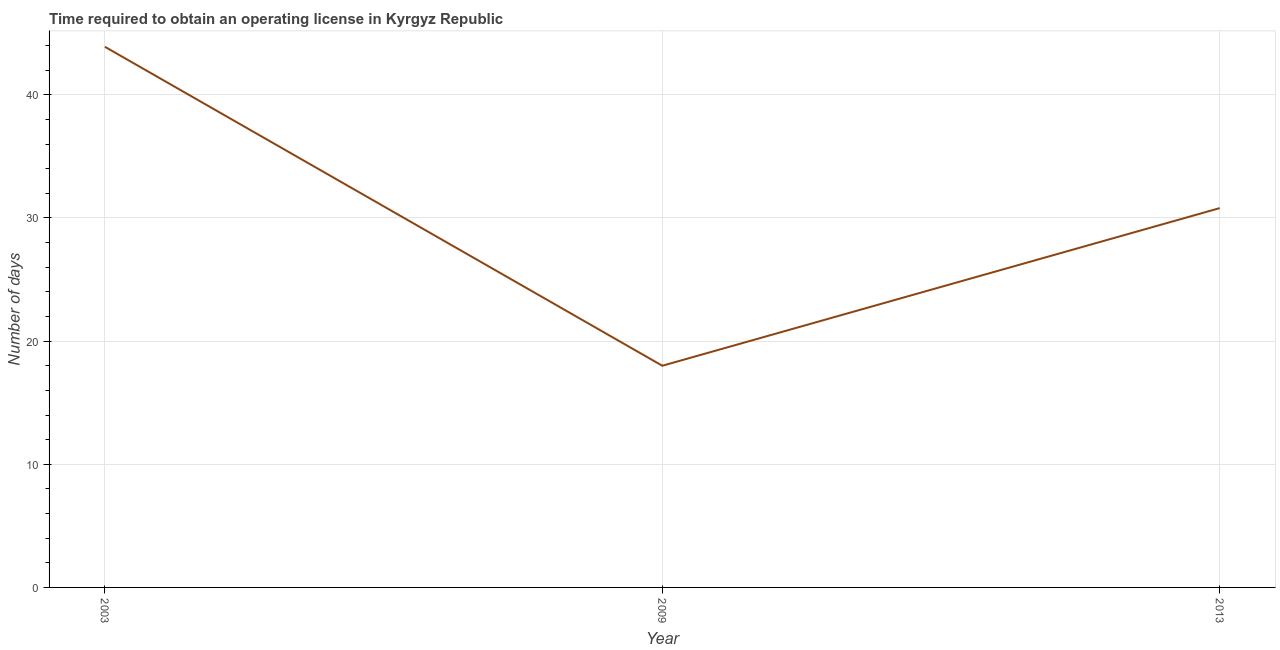What is the number of days to obtain operating license in 2013?
Provide a succinct answer. 30.8. Across all years, what is the maximum number of days to obtain operating license?
Your response must be concise. 43.9. Across all years, what is the minimum number of days to obtain operating license?
Your response must be concise. 18. In which year was the number of days to obtain operating license maximum?
Offer a terse response. 2003. In which year was the number of days to obtain operating license minimum?
Provide a succinct answer. 2009. What is the sum of the number of days to obtain operating license?
Offer a terse response. 92.7. What is the average number of days to obtain operating license per year?
Your answer should be compact. 30.9. What is the median number of days to obtain operating license?
Keep it short and to the point. 30.8. In how many years, is the number of days to obtain operating license greater than 36 days?
Offer a very short reply. 1. What is the ratio of the number of days to obtain operating license in 2003 to that in 2009?
Give a very brief answer. 2.44. What is the difference between the highest and the second highest number of days to obtain operating license?
Your answer should be very brief. 13.1. What is the difference between the highest and the lowest number of days to obtain operating license?
Keep it short and to the point. 25.9. In how many years, is the number of days to obtain operating license greater than the average number of days to obtain operating license taken over all years?
Offer a very short reply. 1. How many lines are there?
Keep it short and to the point. 1. How many years are there in the graph?
Your answer should be compact. 3. Does the graph contain any zero values?
Give a very brief answer. No. Does the graph contain grids?
Provide a short and direct response. Yes. What is the title of the graph?
Offer a terse response. Time required to obtain an operating license in Kyrgyz Republic. What is the label or title of the X-axis?
Provide a short and direct response. Year. What is the label or title of the Y-axis?
Ensure brevity in your answer.  Number of days. What is the Number of days in 2003?
Keep it short and to the point. 43.9. What is the Number of days in 2009?
Offer a terse response. 18. What is the Number of days in 2013?
Make the answer very short. 30.8. What is the difference between the Number of days in 2003 and 2009?
Offer a terse response. 25.9. What is the difference between the Number of days in 2003 and 2013?
Offer a very short reply. 13.1. What is the difference between the Number of days in 2009 and 2013?
Give a very brief answer. -12.8. What is the ratio of the Number of days in 2003 to that in 2009?
Keep it short and to the point. 2.44. What is the ratio of the Number of days in 2003 to that in 2013?
Ensure brevity in your answer.  1.43. What is the ratio of the Number of days in 2009 to that in 2013?
Provide a succinct answer. 0.58. 